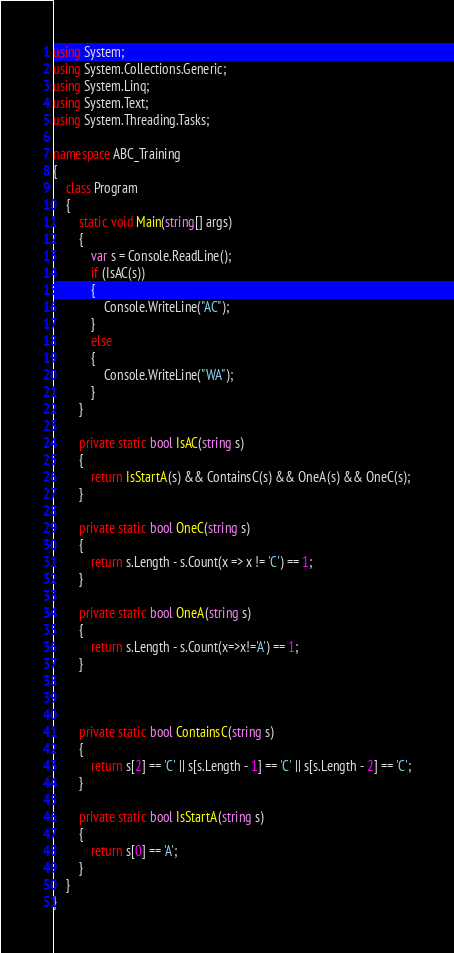Convert code to text. <code><loc_0><loc_0><loc_500><loc_500><_C#_>using System;
using System.Collections.Generic;
using System.Linq;
using System.Text;
using System.Threading.Tasks;

namespace ABC_Training
{
    class Program
    {
        static void Main(string[] args)
        {
            var s = Console.ReadLine();
            if (IsAC(s))
            {
                Console.WriteLine("AC");
            }
            else
            {
                Console.WriteLine("WA");
            }
        }

        private static bool IsAC(string s)
        {
            return IsStartA(s) && ContainsC(s) && OneA(s) && OneC(s);
        }

        private static bool OneC(string s)
        {
            return s.Length - s.Count(x => x != 'C') == 1;
        }

        private static bool OneA(string s)
        {
            return s.Length - s.Count(x=>x!='A') == 1;
        }



        private static bool ContainsC(string s)
        {
            return s[2] == 'C' || s[s.Length - 1] == 'C' || s[s.Length - 2] == 'C';
        }

        private static bool IsStartA(string s)
        {
            return s[0] == 'A';
        }
    }
}
</code> 